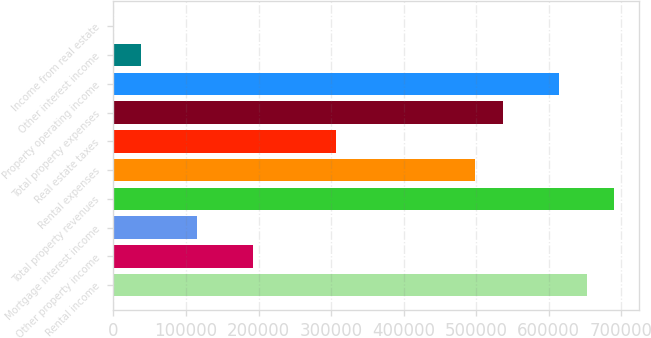Convert chart. <chart><loc_0><loc_0><loc_500><loc_500><bar_chart><fcel>Rental income<fcel>Other property income<fcel>Mortgage interest income<fcel>Total property revenues<fcel>Rental expenses<fcel>Real estate taxes<fcel>Total property expenses<fcel>Property operating income<fcel>Other interest income<fcel>Income from real estate<nl><fcel>651997<fcel>191908<fcel>115227<fcel>690338<fcel>498634<fcel>306931<fcel>536975<fcel>613656<fcel>38545.7<fcel>205<nl></chart> 